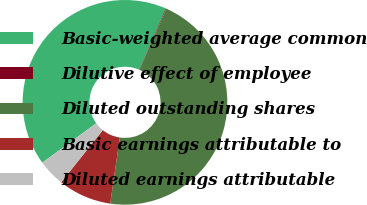Convert chart. <chart><loc_0><loc_0><loc_500><loc_500><pie_chart><fcel>Basic-weighted average common<fcel>Dilutive effect of employee<fcel>Diluted outstanding shares<fcel>Basic earnings attributable to<fcel>Diluted earnings attributable<nl><fcel>41.54%<fcel>0.1%<fcel>45.7%<fcel>8.41%<fcel>4.25%<nl></chart> 